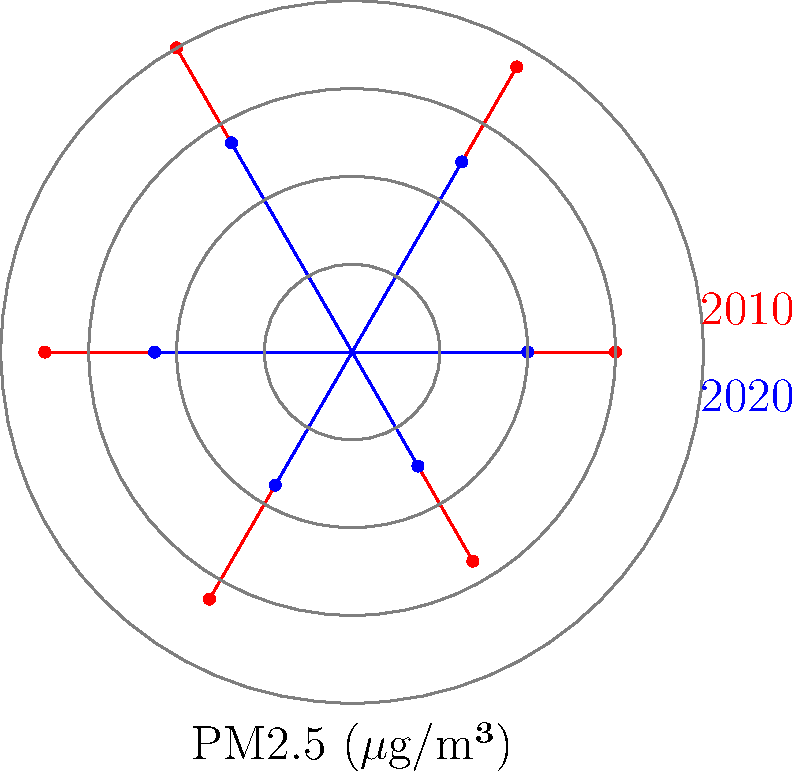Osservando il grafico polare che confronta i livelli di qualità dell'aria urbana nel 2010 e nel 2020, quale conclusione si può trarre riguardo al miglioramento della qualità dell'aria nel corso del decennio? Per rispondere a questa domanda, dobbiamo analizzare il grafico polare passo dopo passo:

1. Il grafico mostra due serie di dati: una in rosso (2010) e una in blu (2020).
2. Ogni serie rappresenta i livelli di PM2.5 (particolato fine) in microgrammi per metro cubo ($\mu$g/m³) in sei diverse misurazioni durante l'anno.
3. I valori sono rappresentati dalla distanza dal centro del grafico: più lontano è il punto, più alto è il livello di PM2.5.
4. Confrontando le due serie:
   a. La serie rossa (2010) ha punti generalmente più lontani dal centro.
   b. La serie blu (2020) ha punti più vicini al centro.
5. Questo indica che i livelli di PM2.5 sono generalmente più bassi nel 2020 rispetto al 2010.
6. Una riduzione dei livelli di PM2.5 implica un miglioramento della qualità dell'aria urbana.
7. La differenza tra le due serie è consistente in tutti i punti di misurazione.

Basandoci su questa analisi, possiamo concludere che c'è stato un significativo miglioramento della qualità dell'aria urbana nel corso del decennio 2010-2020.
Answer: Significativo miglioramento 